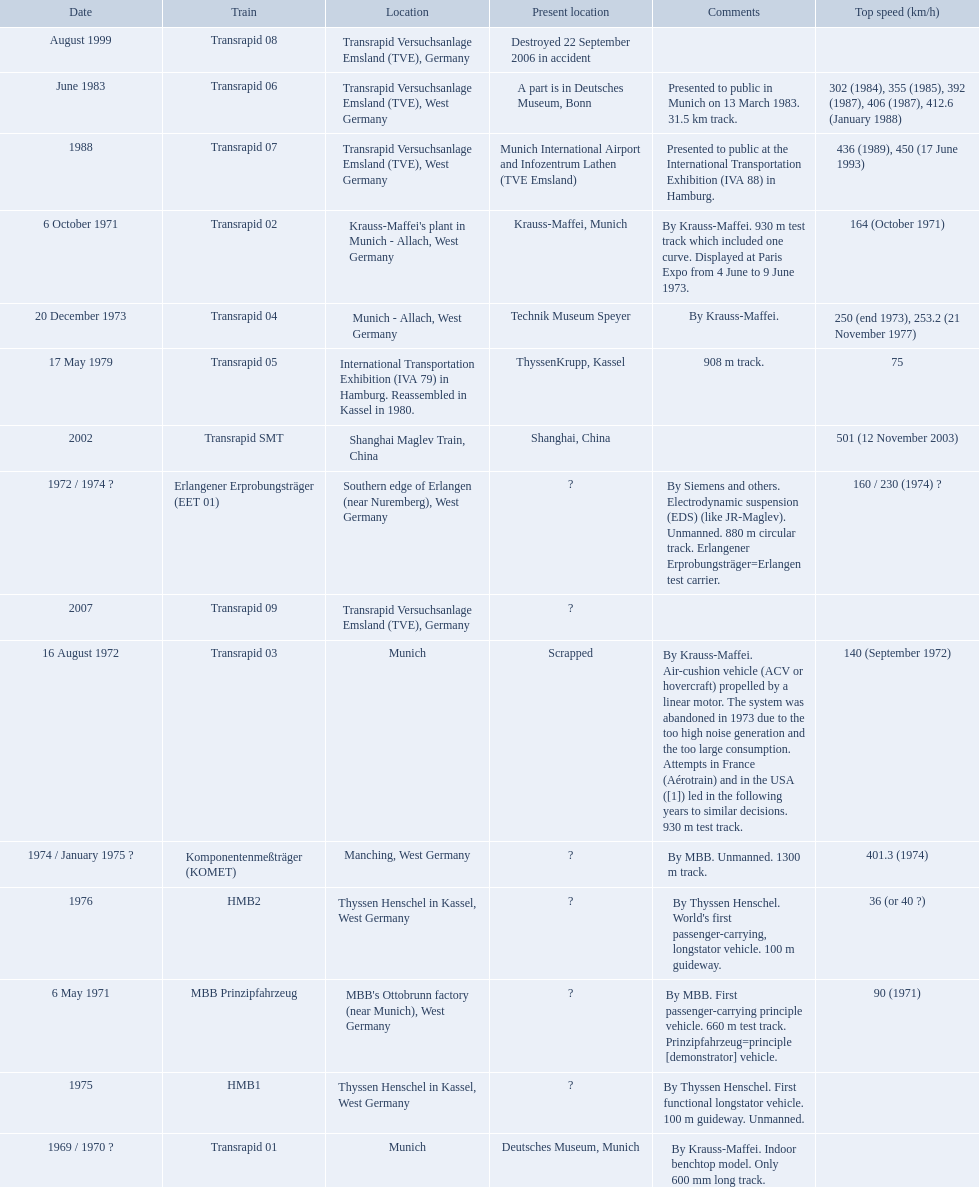Which trains exceeded a top speed of 400+? Komponentenmeßträger (KOMET), Transrapid 07, Transrapid SMT. How about 500+? Transrapid SMT. 